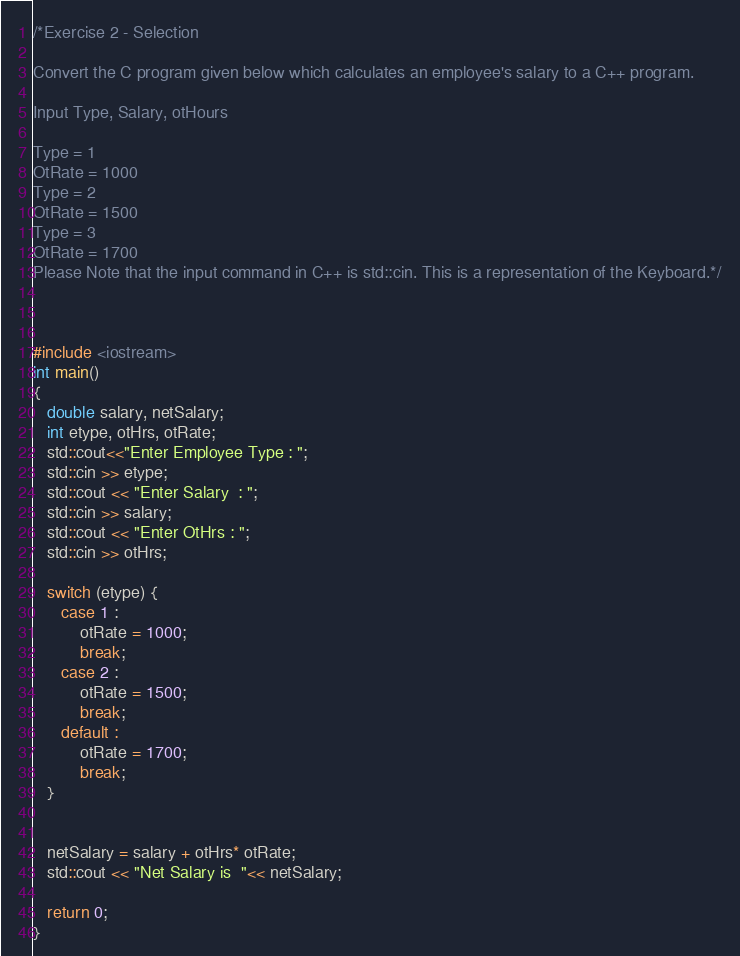<code> <loc_0><loc_0><loc_500><loc_500><_C++_>/*Exercise 2 - Selection

Convert the C program given below which calculates an employee's salary to a C++ program.

Input Type, Salary, otHours

Type = 1
OtRate = 1000
Type = 2
OtRate = 1500
Type = 3
OtRate = 1700
Please Note that the input command in C++ is std::cin. This is a representation of the Keyboard.*/



#include <iostream>
int main()
{
   double salary, netSalary;
   int etype, otHrs, otRate;
   std::cout<<"Enter Employee Type : ";
   std::cin >> etype;
   std::cout << "Enter Salary  : ";
   std::cin >> salary;
   std::cout << "Enter OtHrs : ";
   std::cin >> otHrs; 
   
   switch (etype) {
      case 1 :
          otRate = 1000;
          break;
      case 2 :
          otRate = 1500;
          break;
      default :
          otRate = 1700;
          break;
   }


   netSalary = salary + otHrs* otRate;
   std::cout << "Net Salary is  "<< netSalary;
  
   return 0;
}</code> 